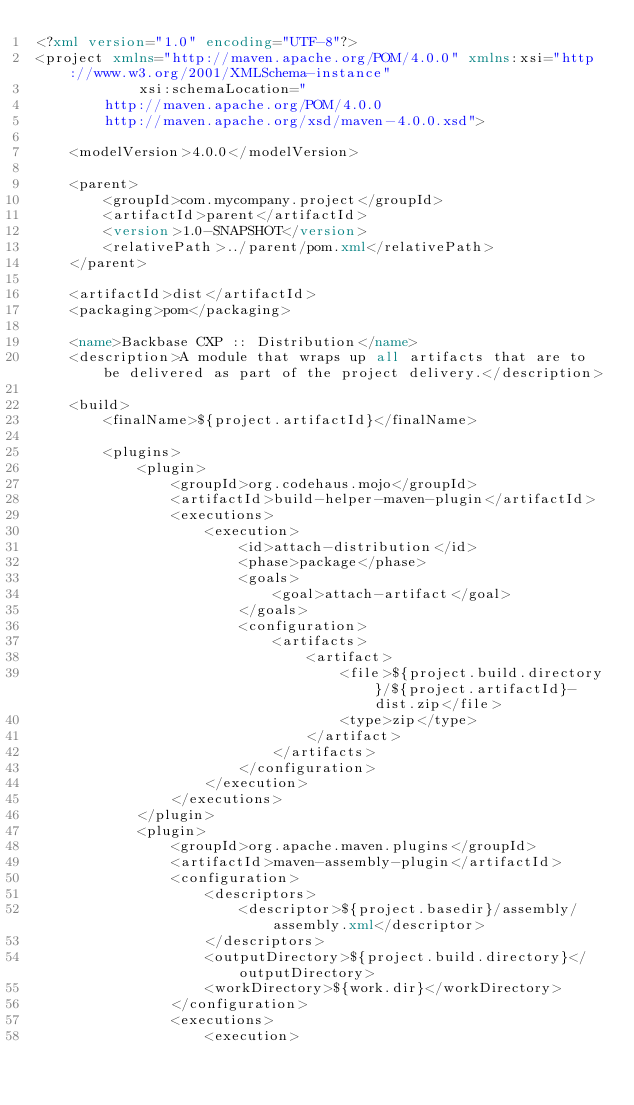<code> <loc_0><loc_0><loc_500><loc_500><_XML_><?xml version="1.0" encoding="UTF-8"?>
<project xmlns="http://maven.apache.org/POM/4.0.0" xmlns:xsi="http://www.w3.org/2001/XMLSchema-instance" 
            xsi:schemaLocation="
        http://maven.apache.org/POM/4.0.0 
        http://maven.apache.org/xsd/maven-4.0.0.xsd">

    <modelVersion>4.0.0</modelVersion>

    <parent>
        <groupId>com.mycompany.project</groupId>
        <artifactId>parent</artifactId>
        <version>1.0-SNAPSHOT</version>
        <relativePath>../parent/pom.xml</relativePath>
    </parent>

    <artifactId>dist</artifactId>
    <packaging>pom</packaging>

    <name>Backbase CXP :: Distribution</name>
    <description>A module that wraps up all artifacts that are to be delivered as part of the project delivery.</description>

    <build>
        <finalName>${project.artifactId}</finalName>

        <plugins>
            <plugin>
                <groupId>org.codehaus.mojo</groupId>
                <artifactId>build-helper-maven-plugin</artifactId>
                <executions>
                    <execution>
                        <id>attach-distribution</id>
                        <phase>package</phase>
                        <goals>
                            <goal>attach-artifact</goal>
                        </goals>
                        <configuration>
                            <artifacts>
                                <artifact>
                                    <file>${project.build.directory}/${project.artifactId}-dist.zip</file>
                                    <type>zip</type>
                                </artifact>
                            </artifacts>
                        </configuration>
                    </execution>
                </executions>
            </plugin>
            <plugin>
                <groupId>org.apache.maven.plugins</groupId>
                <artifactId>maven-assembly-plugin</artifactId>
                <configuration>
                    <descriptors>
                        <descriptor>${project.basedir}/assembly/assembly.xml</descriptor>
                    </descriptors>
                    <outputDirectory>${project.build.directory}</outputDirectory>
                    <workDirectory>${work.dir}</workDirectory>
                </configuration>
                <executions>
                    <execution></code> 